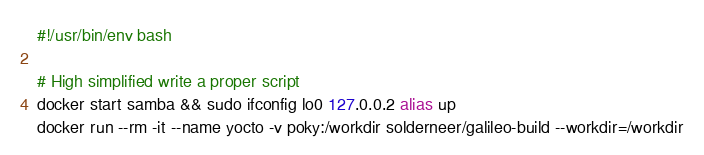Convert code to text. <code><loc_0><loc_0><loc_500><loc_500><_Bash_>#!/usr/bin/env bash

# High simplified write a proper script
docker start samba && sudo ifconfig lo0 127.0.0.2 alias up
docker run --rm -it --name yocto -v poky:/workdir solderneer/galileo-build --workdir=/workdir
</code> 